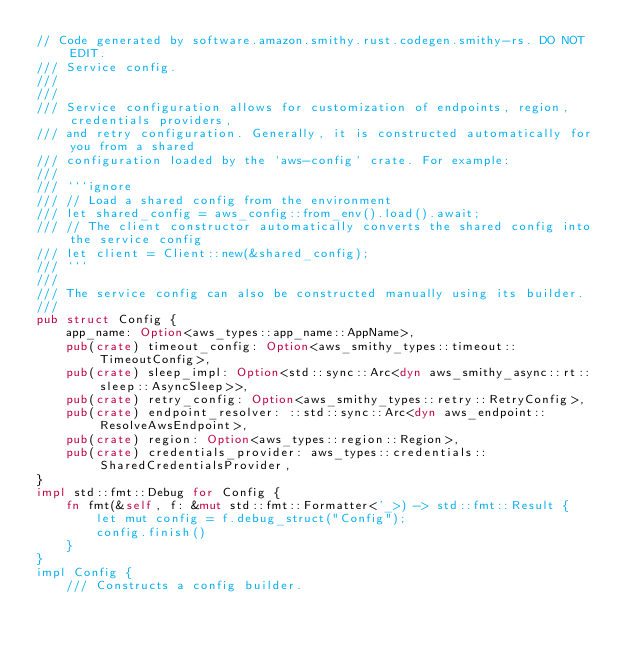<code> <loc_0><loc_0><loc_500><loc_500><_Rust_>// Code generated by software.amazon.smithy.rust.codegen.smithy-rs. DO NOT EDIT.
/// Service config.
///
///
/// Service configuration allows for customization of endpoints, region, credentials providers,
/// and retry configuration. Generally, it is constructed automatically for you from a shared
/// configuration loaded by the `aws-config` crate. For example:
///
/// ```ignore
/// // Load a shared config from the environment
/// let shared_config = aws_config::from_env().load().await;
/// // The client constructor automatically converts the shared config into the service config
/// let client = Client::new(&shared_config);
/// ```
///
/// The service config can also be constructed manually using its builder.
///
pub struct Config {
    app_name: Option<aws_types::app_name::AppName>,
    pub(crate) timeout_config: Option<aws_smithy_types::timeout::TimeoutConfig>,
    pub(crate) sleep_impl: Option<std::sync::Arc<dyn aws_smithy_async::rt::sleep::AsyncSleep>>,
    pub(crate) retry_config: Option<aws_smithy_types::retry::RetryConfig>,
    pub(crate) endpoint_resolver: ::std::sync::Arc<dyn aws_endpoint::ResolveAwsEndpoint>,
    pub(crate) region: Option<aws_types::region::Region>,
    pub(crate) credentials_provider: aws_types::credentials::SharedCredentialsProvider,
}
impl std::fmt::Debug for Config {
    fn fmt(&self, f: &mut std::fmt::Formatter<'_>) -> std::fmt::Result {
        let mut config = f.debug_struct("Config");
        config.finish()
    }
}
impl Config {
    /// Constructs a config builder.</code> 